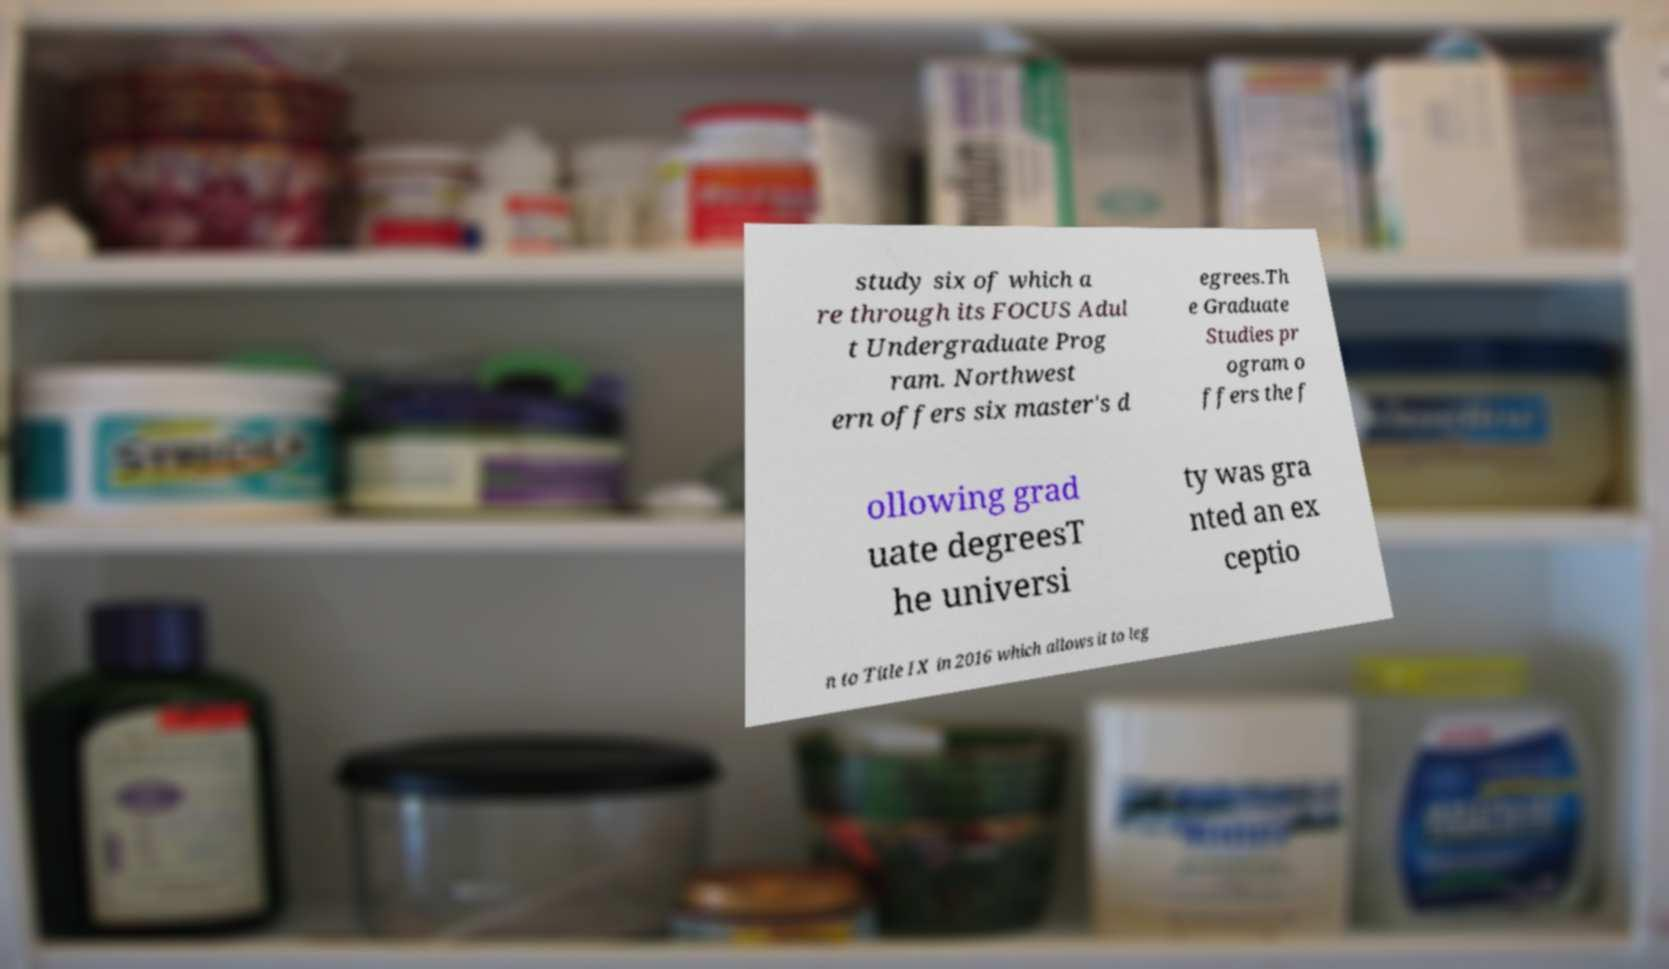There's text embedded in this image that I need extracted. Can you transcribe it verbatim? study six of which a re through its FOCUS Adul t Undergraduate Prog ram. Northwest ern offers six master's d egrees.Th e Graduate Studies pr ogram o ffers the f ollowing grad uate degreesT he universi ty was gra nted an ex ceptio n to Title IX in 2016 which allows it to leg 